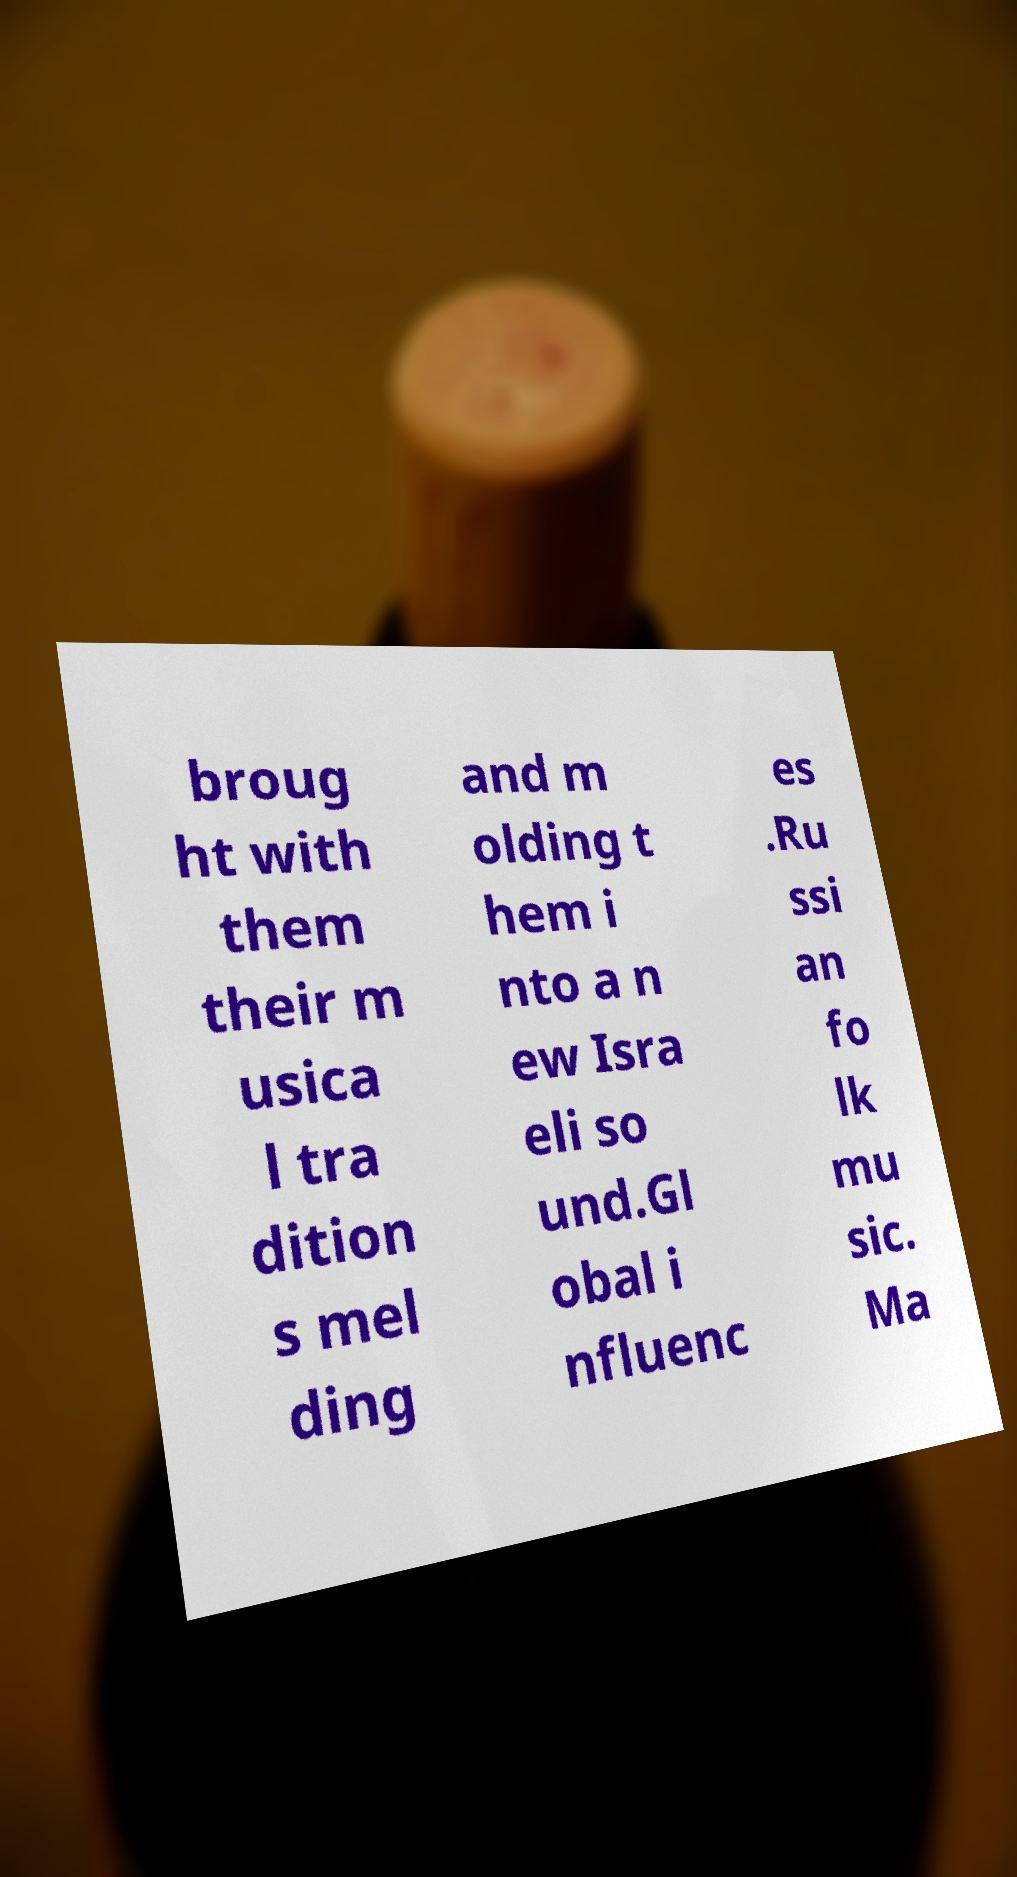For documentation purposes, I need the text within this image transcribed. Could you provide that? broug ht with them their m usica l tra dition s mel ding and m olding t hem i nto a n ew Isra eli so und.Gl obal i nfluenc es .Ru ssi an fo lk mu sic. Ma 